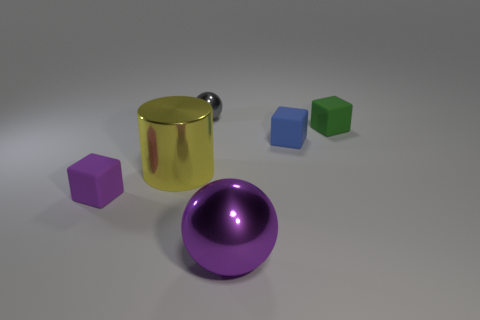Subtract all purple rubber cubes. How many cubes are left? 2 Subtract all blue blocks. How many blocks are left? 2 Add 2 tiny blue metal objects. How many tiny blue metal objects exist? 2 Add 1 brown shiny spheres. How many objects exist? 7 Subtract 0 brown cylinders. How many objects are left? 6 Subtract all cylinders. How many objects are left? 5 Subtract 1 cylinders. How many cylinders are left? 0 Subtract all purple cubes. Subtract all brown cylinders. How many cubes are left? 2 Subtract all yellow blocks. How many blue cylinders are left? 0 Subtract all metallic objects. Subtract all purple things. How many objects are left? 1 